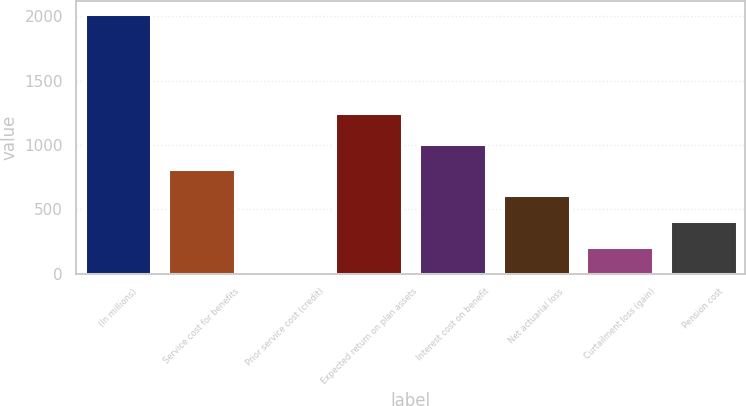<chart> <loc_0><loc_0><loc_500><loc_500><bar_chart><fcel>(In millions)<fcel>Service cost for benefits<fcel>Prior service cost (credit)<fcel>Expected return on plan assets<fcel>Interest cost on benefit<fcel>Net actuarial loss<fcel>Curtailment loss (gain)<fcel>Pension cost<nl><fcel>2017<fcel>809.8<fcel>5<fcel>1249<fcel>1011<fcel>608.6<fcel>206.2<fcel>407.4<nl></chart> 